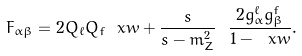<formula> <loc_0><loc_0><loc_500><loc_500>F _ { \alpha \beta } = 2 Q _ { \ell } Q _ { f } \ x w + \frac { s } { s - m ^ { 2 } _ { Z } } \ \frac { 2 g ^ { \ell } _ { \alpha } g ^ { f } _ { \beta } } { 1 - \ x w } .</formula> 